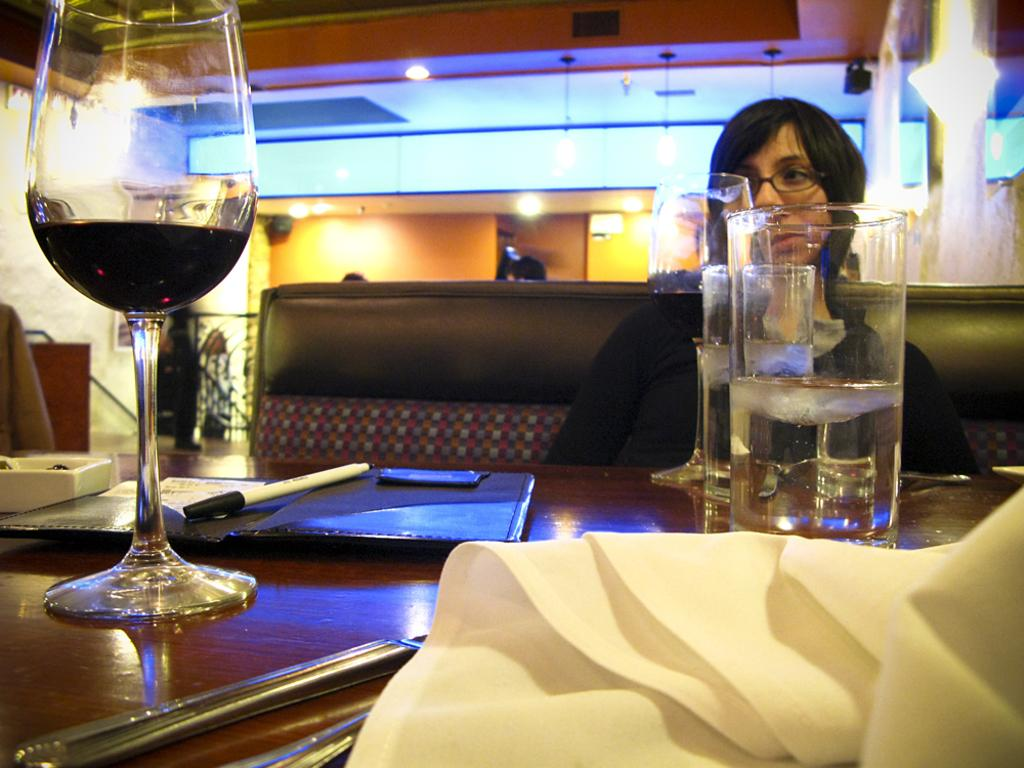What is the woman in the image doing? The woman is sitting on the sofa. What can be seen at the left side of the image? There is a wine glass at the left side of the image. What is visible at the top of the image? There is a light at the top of the image. Can you see any veins in the woman's hand in the image? There is no visible detail of the woman's hand in the image, so it is not possible to determine if any veins are present. 